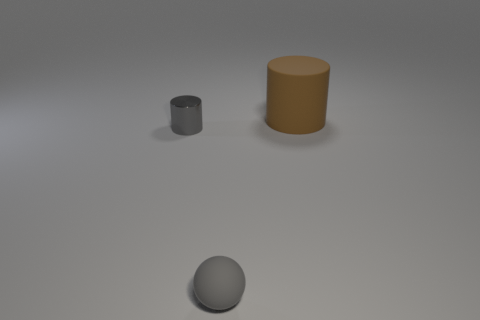Add 1 purple matte things. How many objects exist? 4 Subtract all spheres. How many objects are left? 2 Add 2 gray objects. How many gray objects are left? 4 Add 2 metallic cylinders. How many metallic cylinders exist? 3 Subtract 1 brown cylinders. How many objects are left? 2 Subtract all small metal cylinders. Subtract all tiny cyan matte cylinders. How many objects are left? 2 